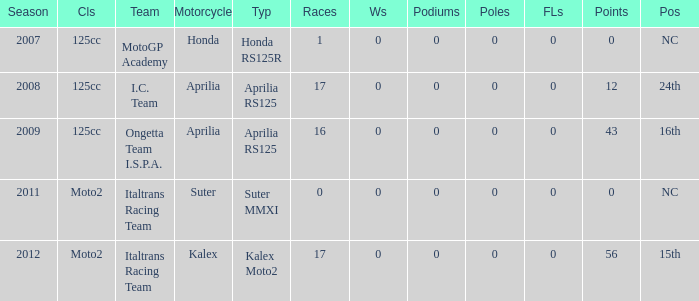How many fastest laps did I.C. Team have? 1.0. 